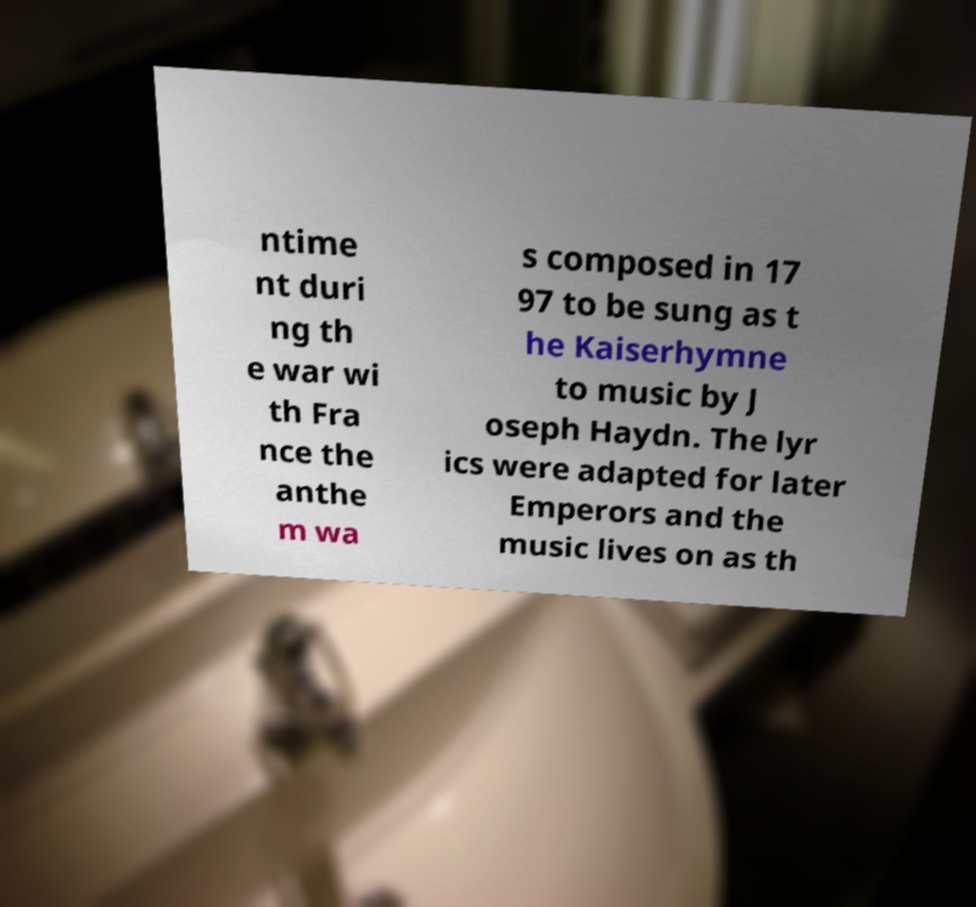Could you assist in decoding the text presented in this image and type it out clearly? ntime nt duri ng th e war wi th Fra nce the anthe m wa s composed in 17 97 to be sung as t he Kaiserhymne to music by J oseph Haydn. The lyr ics were adapted for later Emperors and the music lives on as th 